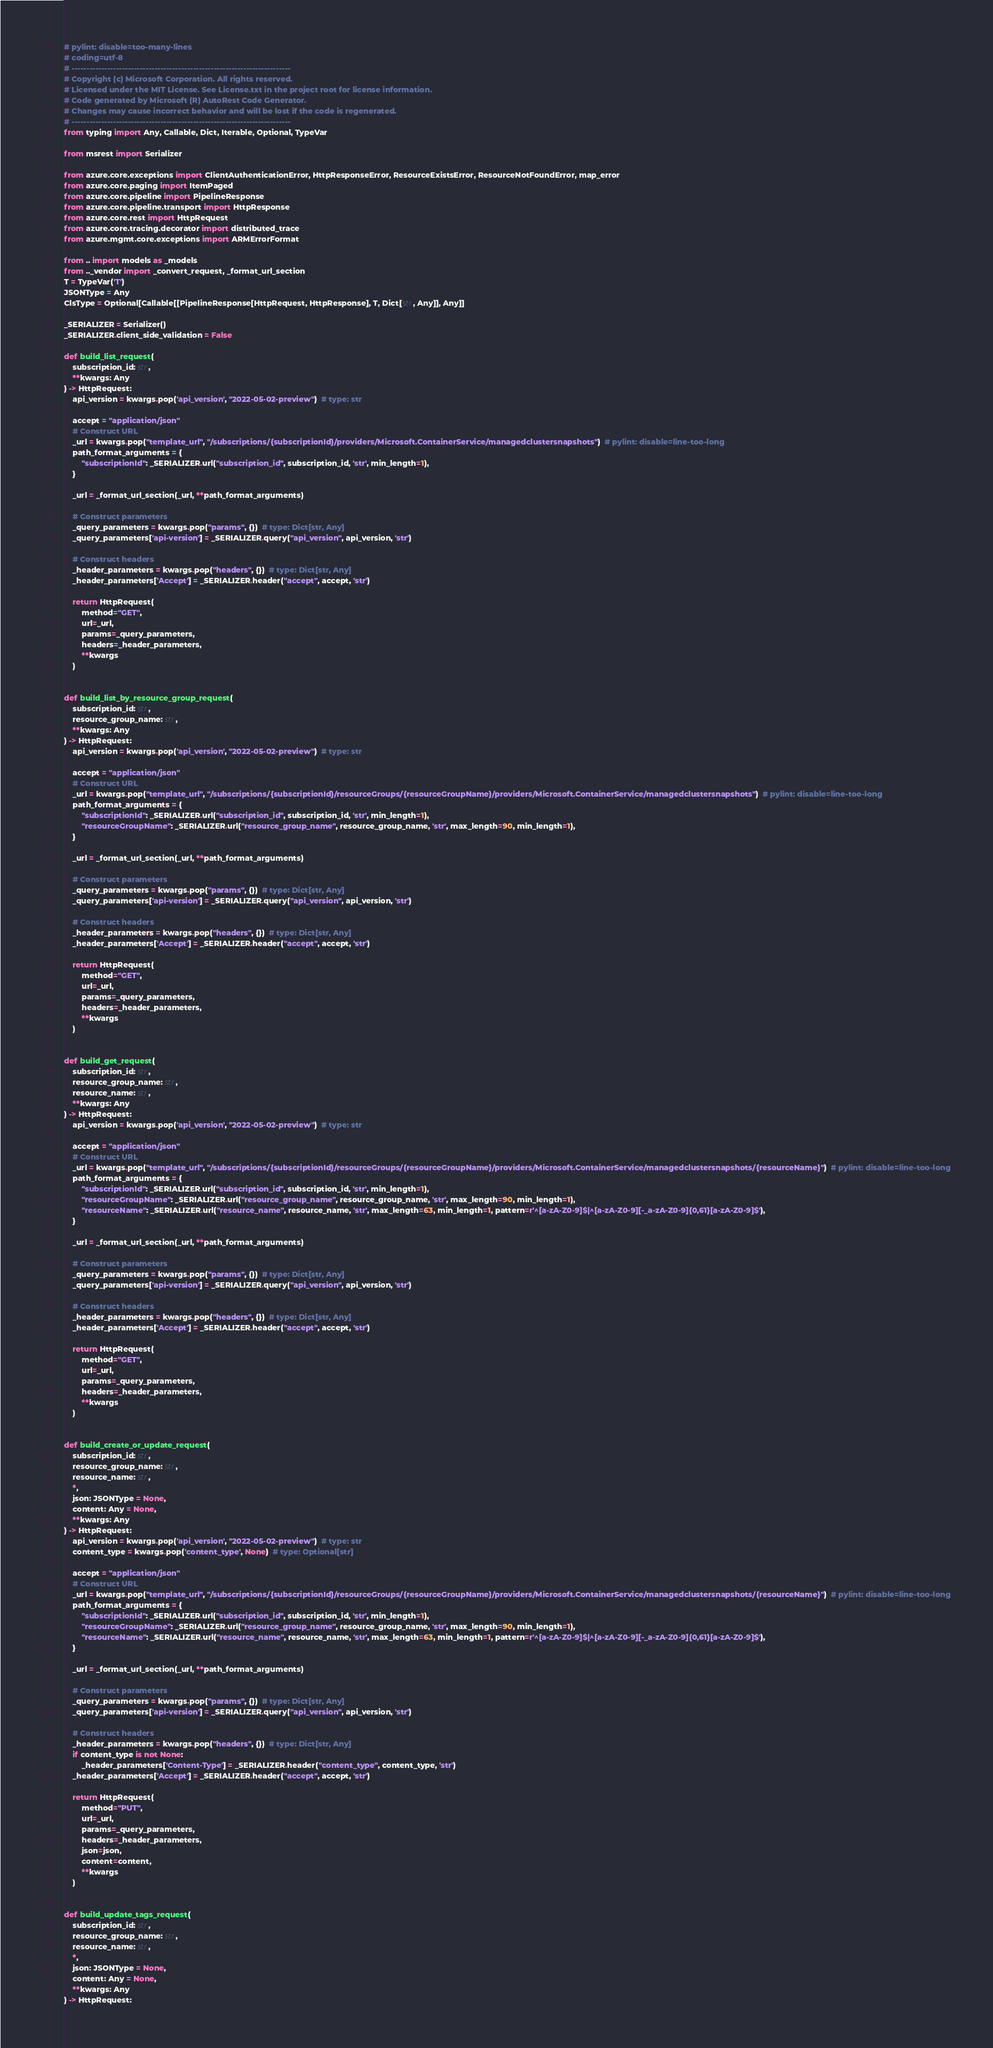<code> <loc_0><loc_0><loc_500><loc_500><_Python_># pylint: disable=too-many-lines
# coding=utf-8
# --------------------------------------------------------------------------
# Copyright (c) Microsoft Corporation. All rights reserved.
# Licensed under the MIT License. See License.txt in the project root for license information.
# Code generated by Microsoft (R) AutoRest Code Generator.
# Changes may cause incorrect behavior and will be lost if the code is regenerated.
# --------------------------------------------------------------------------
from typing import Any, Callable, Dict, Iterable, Optional, TypeVar

from msrest import Serializer

from azure.core.exceptions import ClientAuthenticationError, HttpResponseError, ResourceExistsError, ResourceNotFoundError, map_error
from azure.core.paging import ItemPaged
from azure.core.pipeline import PipelineResponse
from azure.core.pipeline.transport import HttpResponse
from azure.core.rest import HttpRequest
from azure.core.tracing.decorator import distributed_trace
from azure.mgmt.core.exceptions import ARMErrorFormat

from .. import models as _models
from .._vendor import _convert_request, _format_url_section
T = TypeVar('T')
JSONType = Any
ClsType = Optional[Callable[[PipelineResponse[HttpRequest, HttpResponse], T, Dict[str, Any]], Any]]

_SERIALIZER = Serializer()
_SERIALIZER.client_side_validation = False

def build_list_request(
    subscription_id: str,
    **kwargs: Any
) -> HttpRequest:
    api_version = kwargs.pop('api_version', "2022-05-02-preview")  # type: str

    accept = "application/json"
    # Construct URL
    _url = kwargs.pop("template_url", "/subscriptions/{subscriptionId}/providers/Microsoft.ContainerService/managedclustersnapshots")  # pylint: disable=line-too-long
    path_format_arguments = {
        "subscriptionId": _SERIALIZER.url("subscription_id", subscription_id, 'str', min_length=1),
    }

    _url = _format_url_section(_url, **path_format_arguments)

    # Construct parameters
    _query_parameters = kwargs.pop("params", {})  # type: Dict[str, Any]
    _query_parameters['api-version'] = _SERIALIZER.query("api_version", api_version, 'str')

    # Construct headers
    _header_parameters = kwargs.pop("headers", {})  # type: Dict[str, Any]
    _header_parameters['Accept'] = _SERIALIZER.header("accept", accept, 'str')

    return HttpRequest(
        method="GET",
        url=_url,
        params=_query_parameters,
        headers=_header_parameters,
        **kwargs
    )


def build_list_by_resource_group_request(
    subscription_id: str,
    resource_group_name: str,
    **kwargs: Any
) -> HttpRequest:
    api_version = kwargs.pop('api_version', "2022-05-02-preview")  # type: str

    accept = "application/json"
    # Construct URL
    _url = kwargs.pop("template_url", "/subscriptions/{subscriptionId}/resourceGroups/{resourceGroupName}/providers/Microsoft.ContainerService/managedclustersnapshots")  # pylint: disable=line-too-long
    path_format_arguments = {
        "subscriptionId": _SERIALIZER.url("subscription_id", subscription_id, 'str', min_length=1),
        "resourceGroupName": _SERIALIZER.url("resource_group_name", resource_group_name, 'str', max_length=90, min_length=1),
    }

    _url = _format_url_section(_url, **path_format_arguments)

    # Construct parameters
    _query_parameters = kwargs.pop("params", {})  # type: Dict[str, Any]
    _query_parameters['api-version'] = _SERIALIZER.query("api_version", api_version, 'str')

    # Construct headers
    _header_parameters = kwargs.pop("headers", {})  # type: Dict[str, Any]
    _header_parameters['Accept'] = _SERIALIZER.header("accept", accept, 'str')

    return HttpRequest(
        method="GET",
        url=_url,
        params=_query_parameters,
        headers=_header_parameters,
        **kwargs
    )


def build_get_request(
    subscription_id: str,
    resource_group_name: str,
    resource_name: str,
    **kwargs: Any
) -> HttpRequest:
    api_version = kwargs.pop('api_version', "2022-05-02-preview")  # type: str

    accept = "application/json"
    # Construct URL
    _url = kwargs.pop("template_url", "/subscriptions/{subscriptionId}/resourceGroups/{resourceGroupName}/providers/Microsoft.ContainerService/managedclustersnapshots/{resourceName}")  # pylint: disable=line-too-long
    path_format_arguments = {
        "subscriptionId": _SERIALIZER.url("subscription_id", subscription_id, 'str', min_length=1),
        "resourceGroupName": _SERIALIZER.url("resource_group_name", resource_group_name, 'str', max_length=90, min_length=1),
        "resourceName": _SERIALIZER.url("resource_name", resource_name, 'str', max_length=63, min_length=1, pattern=r'^[a-zA-Z0-9]$|^[a-zA-Z0-9][-_a-zA-Z0-9]{0,61}[a-zA-Z0-9]$'),
    }

    _url = _format_url_section(_url, **path_format_arguments)

    # Construct parameters
    _query_parameters = kwargs.pop("params", {})  # type: Dict[str, Any]
    _query_parameters['api-version'] = _SERIALIZER.query("api_version", api_version, 'str')

    # Construct headers
    _header_parameters = kwargs.pop("headers", {})  # type: Dict[str, Any]
    _header_parameters['Accept'] = _SERIALIZER.header("accept", accept, 'str')

    return HttpRequest(
        method="GET",
        url=_url,
        params=_query_parameters,
        headers=_header_parameters,
        **kwargs
    )


def build_create_or_update_request(
    subscription_id: str,
    resource_group_name: str,
    resource_name: str,
    *,
    json: JSONType = None,
    content: Any = None,
    **kwargs: Any
) -> HttpRequest:
    api_version = kwargs.pop('api_version', "2022-05-02-preview")  # type: str
    content_type = kwargs.pop('content_type', None)  # type: Optional[str]

    accept = "application/json"
    # Construct URL
    _url = kwargs.pop("template_url", "/subscriptions/{subscriptionId}/resourceGroups/{resourceGroupName}/providers/Microsoft.ContainerService/managedclustersnapshots/{resourceName}")  # pylint: disable=line-too-long
    path_format_arguments = {
        "subscriptionId": _SERIALIZER.url("subscription_id", subscription_id, 'str', min_length=1),
        "resourceGroupName": _SERIALIZER.url("resource_group_name", resource_group_name, 'str', max_length=90, min_length=1),
        "resourceName": _SERIALIZER.url("resource_name", resource_name, 'str', max_length=63, min_length=1, pattern=r'^[a-zA-Z0-9]$|^[a-zA-Z0-9][-_a-zA-Z0-9]{0,61}[a-zA-Z0-9]$'),
    }

    _url = _format_url_section(_url, **path_format_arguments)

    # Construct parameters
    _query_parameters = kwargs.pop("params", {})  # type: Dict[str, Any]
    _query_parameters['api-version'] = _SERIALIZER.query("api_version", api_version, 'str')

    # Construct headers
    _header_parameters = kwargs.pop("headers", {})  # type: Dict[str, Any]
    if content_type is not None:
        _header_parameters['Content-Type'] = _SERIALIZER.header("content_type", content_type, 'str')
    _header_parameters['Accept'] = _SERIALIZER.header("accept", accept, 'str')

    return HttpRequest(
        method="PUT",
        url=_url,
        params=_query_parameters,
        headers=_header_parameters,
        json=json,
        content=content,
        **kwargs
    )


def build_update_tags_request(
    subscription_id: str,
    resource_group_name: str,
    resource_name: str,
    *,
    json: JSONType = None,
    content: Any = None,
    **kwargs: Any
) -> HttpRequest:</code> 